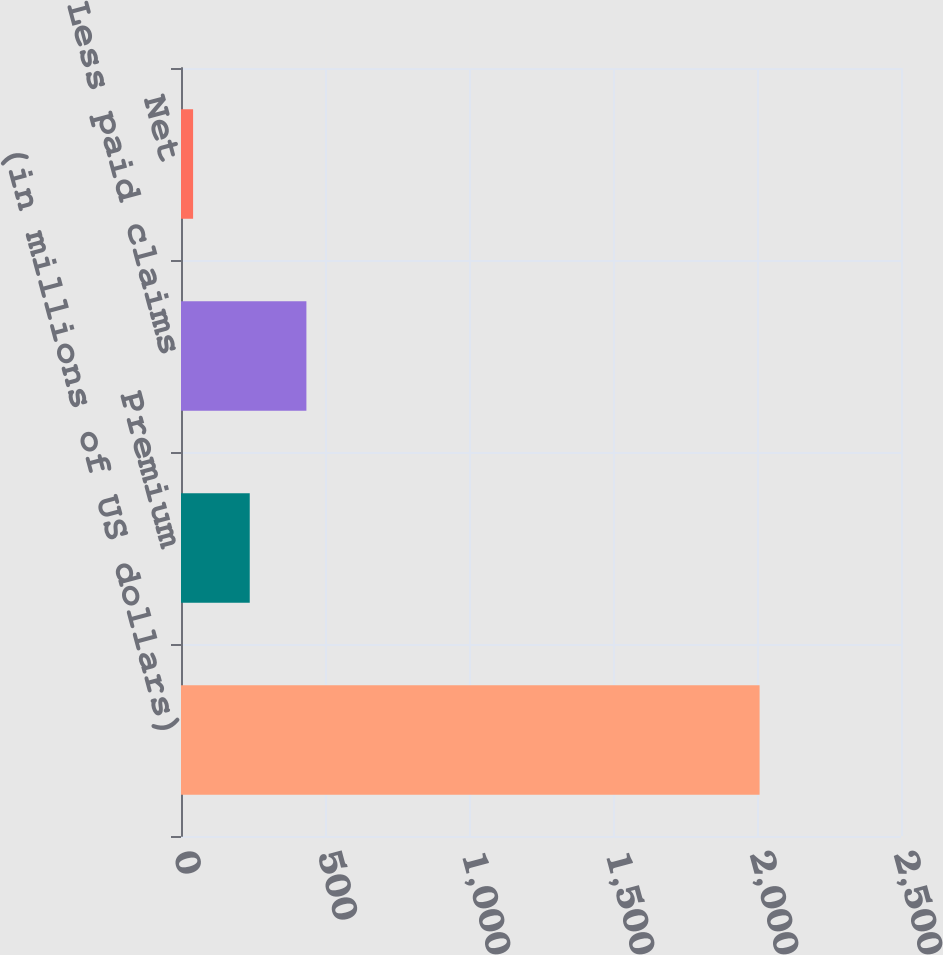Convert chart to OTSL. <chart><loc_0><loc_0><loc_500><loc_500><bar_chart><fcel>(in millions of US dollars)<fcel>Premium<fcel>Less paid claims<fcel>Net<nl><fcel>2009<fcel>238.7<fcel>435.4<fcel>42<nl></chart> 